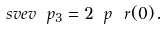<formula> <loc_0><loc_0><loc_500><loc_500>\ s v e v { \ p _ { 3 } } = 2 \ p \ r ( 0 ) \, .</formula> 